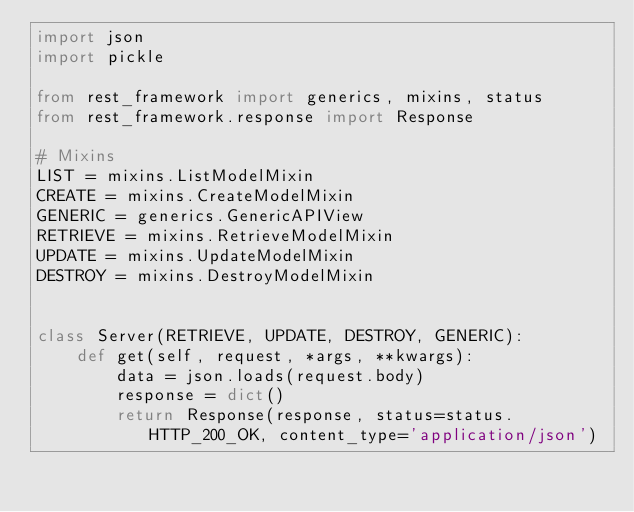<code> <loc_0><loc_0><loc_500><loc_500><_Python_>import json
import pickle

from rest_framework import generics, mixins, status
from rest_framework.response import Response

# Mixins
LIST = mixins.ListModelMixin
CREATE = mixins.CreateModelMixin
GENERIC = generics.GenericAPIView
RETRIEVE = mixins.RetrieveModelMixin
UPDATE = mixins.UpdateModelMixin
DESTROY = mixins.DestroyModelMixin


class Server(RETRIEVE, UPDATE, DESTROY, GENERIC):
    def get(self, request, *args, **kwargs):
        data = json.loads(request.body)
        response = dict()
        return Response(response, status=status.HTTP_200_OK, content_type='application/json')
</code> 